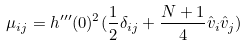Convert formula to latex. <formula><loc_0><loc_0><loc_500><loc_500>\mu _ { i j } = h ^ { \prime \prime \prime } ( 0 ) ^ { 2 } ( \frac { 1 } { 2 } \delta _ { i j } + \frac { N + 1 } { 4 } \hat { v } _ { i } \hat { v } _ { j } )</formula> 